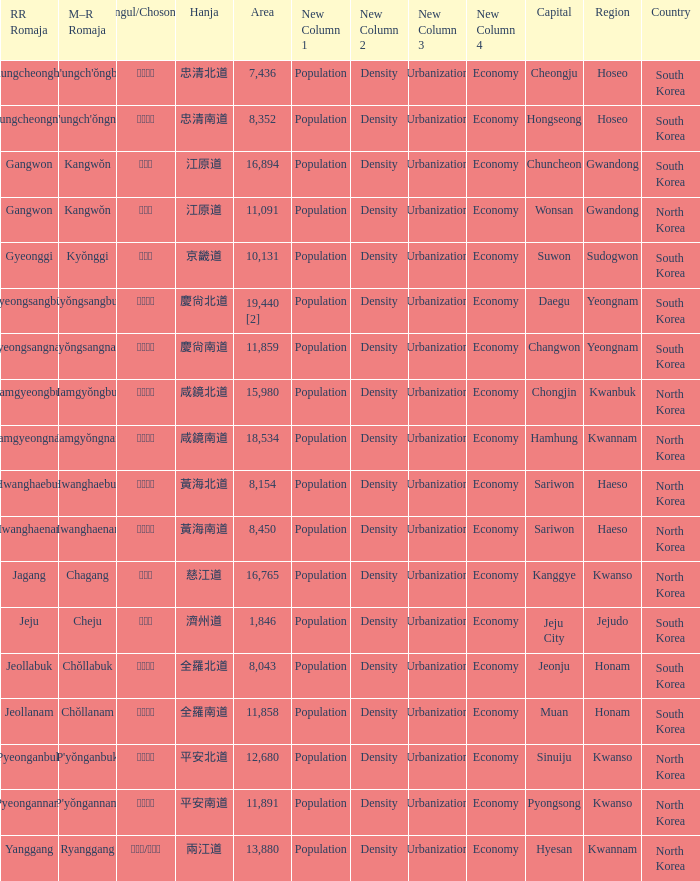What is the RR Romaja for the province that has Hangul of 강원도 and capital of Wonsan? Gangwon. 